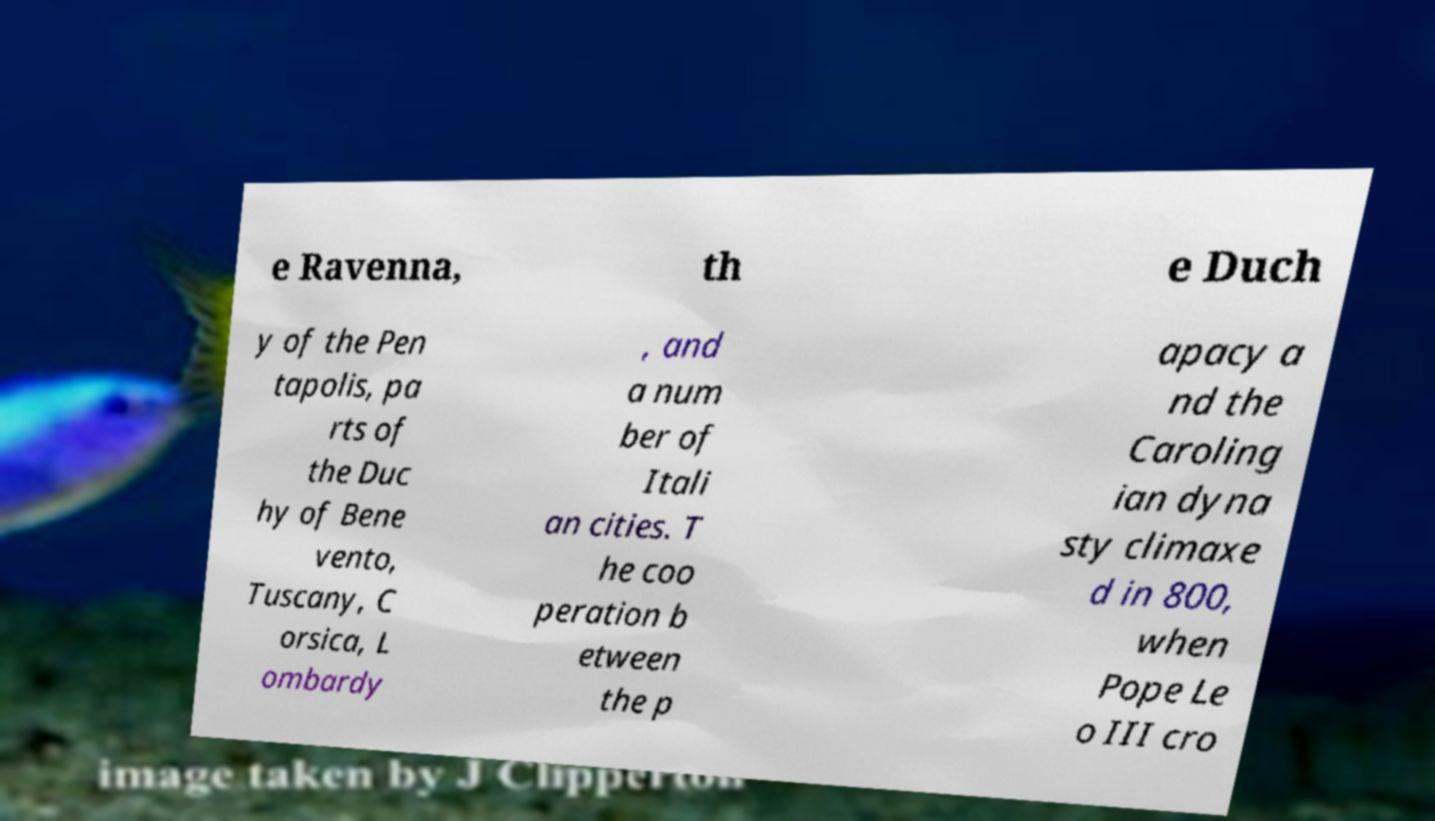Can you read and provide the text displayed in the image?This photo seems to have some interesting text. Can you extract and type it out for me? e Ravenna, th e Duch y of the Pen tapolis, pa rts of the Duc hy of Bene vento, Tuscany, C orsica, L ombardy , and a num ber of Itali an cities. T he coo peration b etween the p apacy a nd the Caroling ian dyna sty climaxe d in 800, when Pope Le o III cro 